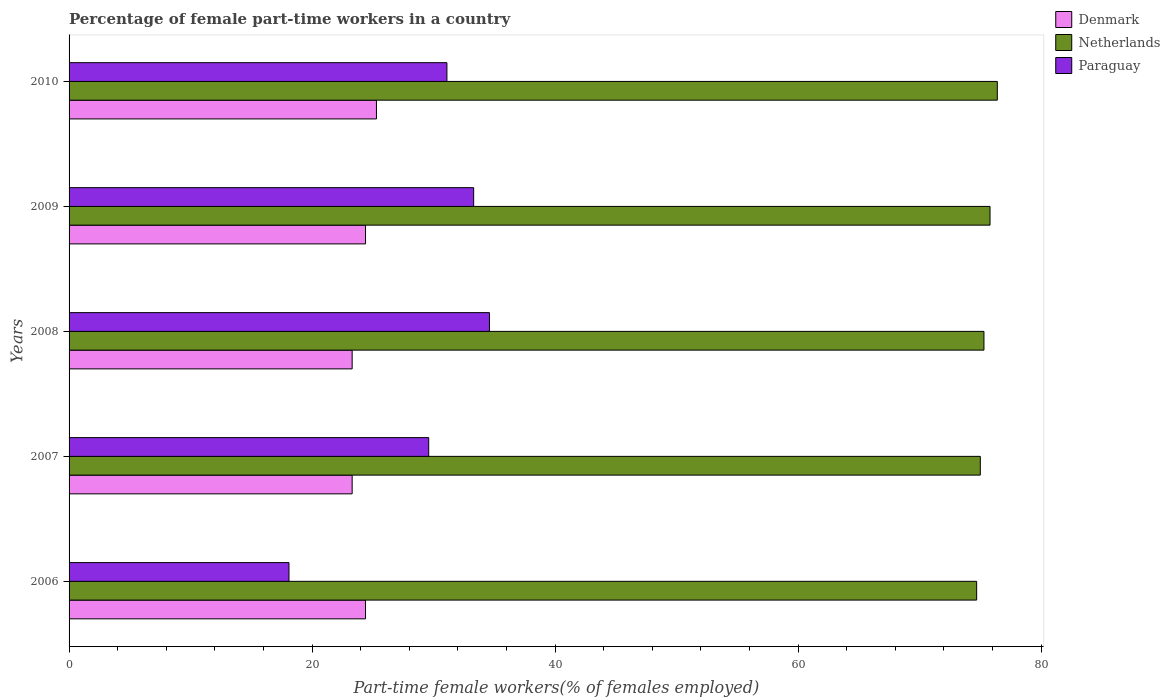How many different coloured bars are there?
Provide a short and direct response. 3. What is the label of the 2nd group of bars from the top?
Make the answer very short. 2009. What is the percentage of female part-time workers in Netherlands in 2009?
Your response must be concise. 75.8. Across all years, what is the maximum percentage of female part-time workers in Netherlands?
Your response must be concise. 76.4. Across all years, what is the minimum percentage of female part-time workers in Denmark?
Keep it short and to the point. 23.3. In which year was the percentage of female part-time workers in Netherlands maximum?
Your answer should be compact. 2010. What is the total percentage of female part-time workers in Paraguay in the graph?
Your response must be concise. 146.7. What is the difference between the percentage of female part-time workers in Paraguay in 2006 and that in 2009?
Your answer should be very brief. -15.2. What is the difference between the percentage of female part-time workers in Paraguay in 2010 and the percentage of female part-time workers in Denmark in 2007?
Your answer should be very brief. 7.8. What is the average percentage of female part-time workers in Netherlands per year?
Offer a very short reply. 75.44. In the year 2010, what is the difference between the percentage of female part-time workers in Denmark and percentage of female part-time workers in Paraguay?
Provide a short and direct response. -5.8. In how many years, is the percentage of female part-time workers in Paraguay greater than 60 %?
Your answer should be very brief. 0. What is the ratio of the percentage of female part-time workers in Denmark in 2006 to that in 2007?
Your answer should be compact. 1.05. What is the difference between the highest and the second highest percentage of female part-time workers in Denmark?
Provide a succinct answer. 0.9. What is the difference between the highest and the lowest percentage of female part-time workers in Netherlands?
Offer a very short reply. 1.7. In how many years, is the percentage of female part-time workers in Netherlands greater than the average percentage of female part-time workers in Netherlands taken over all years?
Give a very brief answer. 2. What does the 2nd bar from the top in 2006 represents?
Your answer should be compact. Netherlands. What does the 3rd bar from the bottom in 2009 represents?
Your answer should be compact. Paraguay. Is it the case that in every year, the sum of the percentage of female part-time workers in Denmark and percentage of female part-time workers in Netherlands is greater than the percentage of female part-time workers in Paraguay?
Make the answer very short. Yes. How many bars are there?
Offer a terse response. 15. How many years are there in the graph?
Provide a short and direct response. 5. Does the graph contain grids?
Keep it short and to the point. No. Where does the legend appear in the graph?
Give a very brief answer. Top right. What is the title of the graph?
Your response must be concise. Percentage of female part-time workers in a country. Does "Kosovo" appear as one of the legend labels in the graph?
Keep it short and to the point. No. What is the label or title of the X-axis?
Give a very brief answer. Part-time female workers(% of females employed). What is the Part-time female workers(% of females employed) of Denmark in 2006?
Offer a terse response. 24.4. What is the Part-time female workers(% of females employed) in Netherlands in 2006?
Offer a very short reply. 74.7. What is the Part-time female workers(% of females employed) of Paraguay in 2006?
Ensure brevity in your answer.  18.1. What is the Part-time female workers(% of females employed) in Denmark in 2007?
Your response must be concise. 23.3. What is the Part-time female workers(% of females employed) in Netherlands in 2007?
Offer a terse response. 75. What is the Part-time female workers(% of females employed) of Paraguay in 2007?
Offer a terse response. 29.6. What is the Part-time female workers(% of females employed) in Denmark in 2008?
Keep it short and to the point. 23.3. What is the Part-time female workers(% of females employed) in Netherlands in 2008?
Provide a short and direct response. 75.3. What is the Part-time female workers(% of females employed) in Paraguay in 2008?
Provide a succinct answer. 34.6. What is the Part-time female workers(% of females employed) in Denmark in 2009?
Give a very brief answer. 24.4. What is the Part-time female workers(% of females employed) in Netherlands in 2009?
Offer a very short reply. 75.8. What is the Part-time female workers(% of females employed) in Paraguay in 2009?
Your answer should be very brief. 33.3. What is the Part-time female workers(% of females employed) in Denmark in 2010?
Your response must be concise. 25.3. What is the Part-time female workers(% of females employed) of Netherlands in 2010?
Provide a succinct answer. 76.4. What is the Part-time female workers(% of females employed) of Paraguay in 2010?
Your response must be concise. 31.1. Across all years, what is the maximum Part-time female workers(% of females employed) of Denmark?
Ensure brevity in your answer.  25.3. Across all years, what is the maximum Part-time female workers(% of females employed) of Netherlands?
Provide a short and direct response. 76.4. Across all years, what is the maximum Part-time female workers(% of females employed) in Paraguay?
Give a very brief answer. 34.6. Across all years, what is the minimum Part-time female workers(% of females employed) of Denmark?
Provide a short and direct response. 23.3. Across all years, what is the minimum Part-time female workers(% of females employed) in Netherlands?
Make the answer very short. 74.7. Across all years, what is the minimum Part-time female workers(% of females employed) in Paraguay?
Offer a terse response. 18.1. What is the total Part-time female workers(% of females employed) of Denmark in the graph?
Provide a succinct answer. 120.7. What is the total Part-time female workers(% of females employed) in Netherlands in the graph?
Provide a short and direct response. 377.2. What is the total Part-time female workers(% of females employed) in Paraguay in the graph?
Make the answer very short. 146.7. What is the difference between the Part-time female workers(% of females employed) in Denmark in 2006 and that in 2007?
Ensure brevity in your answer.  1.1. What is the difference between the Part-time female workers(% of females employed) in Netherlands in 2006 and that in 2007?
Provide a succinct answer. -0.3. What is the difference between the Part-time female workers(% of females employed) in Netherlands in 2006 and that in 2008?
Keep it short and to the point. -0.6. What is the difference between the Part-time female workers(% of females employed) in Paraguay in 2006 and that in 2008?
Your answer should be compact. -16.5. What is the difference between the Part-time female workers(% of females employed) of Netherlands in 2006 and that in 2009?
Provide a short and direct response. -1.1. What is the difference between the Part-time female workers(% of females employed) in Paraguay in 2006 and that in 2009?
Your answer should be very brief. -15.2. What is the difference between the Part-time female workers(% of females employed) in Denmark in 2006 and that in 2010?
Provide a succinct answer. -0.9. What is the difference between the Part-time female workers(% of females employed) in Netherlands in 2006 and that in 2010?
Your response must be concise. -1.7. What is the difference between the Part-time female workers(% of females employed) in Denmark in 2007 and that in 2008?
Provide a succinct answer. 0. What is the difference between the Part-time female workers(% of females employed) in Paraguay in 2007 and that in 2008?
Make the answer very short. -5. What is the difference between the Part-time female workers(% of females employed) of Netherlands in 2007 and that in 2009?
Provide a short and direct response. -0.8. What is the difference between the Part-time female workers(% of females employed) in Paraguay in 2007 and that in 2010?
Offer a very short reply. -1.5. What is the difference between the Part-time female workers(% of females employed) of Paraguay in 2008 and that in 2009?
Offer a very short reply. 1.3. What is the difference between the Part-time female workers(% of females employed) in Netherlands in 2009 and that in 2010?
Your answer should be very brief. -0.6. What is the difference between the Part-time female workers(% of females employed) of Paraguay in 2009 and that in 2010?
Your answer should be compact. 2.2. What is the difference between the Part-time female workers(% of females employed) of Denmark in 2006 and the Part-time female workers(% of females employed) of Netherlands in 2007?
Provide a short and direct response. -50.6. What is the difference between the Part-time female workers(% of females employed) in Netherlands in 2006 and the Part-time female workers(% of females employed) in Paraguay in 2007?
Your answer should be very brief. 45.1. What is the difference between the Part-time female workers(% of females employed) in Denmark in 2006 and the Part-time female workers(% of females employed) in Netherlands in 2008?
Offer a very short reply. -50.9. What is the difference between the Part-time female workers(% of females employed) in Netherlands in 2006 and the Part-time female workers(% of females employed) in Paraguay in 2008?
Make the answer very short. 40.1. What is the difference between the Part-time female workers(% of females employed) in Denmark in 2006 and the Part-time female workers(% of females employed) in Netherlands in 2009?
Your answer should be very brief. -51.4. What is the difference between the Part-time female workers(% of females employed) of Denmark in 2006 and the Part-time female workers(% of females employed) of Paraguay in 2009?
Give a very brief answer. -8.9. What is the difference between the Part-time female workers(% of females employed) of Netherlands in 2006 and the Part-time female workers(% of females employed) of Paraguay in 2009?
Give a very brief answer. 41.4. What is the difference between the Part-time female workers(% of females employed) of Denmark in 2006 and the Part-time female workers(% of females employed) of Netherlands in 2010?
Your answer should be very brief. -52. What is the difference between the Part-time female workers(% of females employed) in Netherlands in 2006 and the Part-time female workers(% of females employed) in Paraguay in 2010?
Keep it short and to the point. 43.6. What is the difference between the Part-time female workers(% of females employed) in Denmark in 2007 and the Part-time female workers(% of females employed) in Netherlands in 2008?
Ensure brevity in your answer.  -52. What is the difference between the Part-time female workers(% of females employed) of Denmark in 2007 and the Part-time female workers(% of females employed) of Paraguay in 2008?
Give a very brief answer. -11.3. What is the difference between the Part-time female workers(% of females employed) in Netherlands in 2007 and the Part-time female workers(% of females employed) in Paraguay in 2008?
Give a very brief answer. 40.4. What is the difference between the Part-time female workers(% of females employed) of Denmark in 2007 and the Part-time female workers(% of females employed) of Netherlands in 2009?
Provide a short and direct response. -52.5. What is the difference between the Part-time female workers(% of females employed) in Denmark in 2007 and the Part-time female workers(% of females employed) in Paraguay in 2009?
Provide a short and direct response. -10. What is the difference between the Part-time female workers(% of females employed) in Netherlands in 2007 and the Part-time female workers(% of females employed) in Paraguay in 2009?
Provide a short and direct response. 41.7. What is the difference between the Part-time female workers(% of females employed) of Denmark in 2007 and the Part-time female workers(% of females employed) of Netherlands in 2010?
Give a very brief answer. -53.1. What is the difference between the Part-time female workers(% of females employed) of Netherlands in 2007 and the Part-time female workers(% of females employed) of Paraguay in 2010?
Your answer should be very brief. 43.9. What is the difference between the Part-time female workers(% of females employed) of Denmark in 2008 and the Part-time female workers(% of females employed) of Netherlands in 2009?
Make the answer very short. -52.5. What is the difference between the Part-time female workers(% of females employed) of Denmark in 2008 and the Part-time female workers(% of females employed) of Paraguay in 2009?
Your response must be concise. -10. What is the difference between the Part-time female workers(% of females employed) in Netherlands in 2008 and the Part-time female workers(% of females employed) in Paraguay in 2009?
Provide a short and direct response. 42. What is the difference between the Part-time female workers(% of females employed) of Denmark in 2008 and the Part-time female workers(% of females employed) of Netherlands in 2010?
Your answer should be compact. -53.1. What is the difference between the Part-time female workers(% of females employed) of Denmark in 2008 and the Part-time female workers(% of females employed) of Paraguay in 2010?
Make the answer very short. -7.8. What is the difference between the Part-time female workers(% of females employed) of Netherlands in 2008 and the Part-time female workers(% of females employed) of Paraguay in 2010?
Your response must be concise. 44.2. What is the difference between the Part-time female workers(% of females employed) in Denmark in 2009 and the Part-time female workers(% of females employed) in Netherlands in 2010?
Provide a short and direct response. -52. What is the difference between the Part-time female workers(% of females employed) of Netherlands in 2009 and the Part-time female workers(% of females employed) of Paraguay in 2010?
Give a very brief answer. 44.7. What is the average Part-time female workers(% of females employed) in Denmark per year?
Keep it short and to the point. 24.14. What is the average Part-time female workers(% of females employed) of Netherlands per year?
Your response must be concise. 75.44. What is the average Part-time female workers(% of females employed) of Paraguay per year?
Keep it short and to the point. 29.34. In the year 2006, what is the difference between the Part-time female workers(% of females employed) of Denmark and Part-time female workers(% of females employed) of Netherlands?
Ensure brevity in your answer.  -50.3. In the year 2006, what is the difference between the Part-time female workers(% of females employed) of Netherlands and Part-time female workers(% of females employed) of Paraguay?
Keep it short and to the point. 56.6. In the year 2007, what is the difference between the Part-time female workers(% of females employed) of Denmark and Part-time female workers(% of females employed) of Netherlands?
Make the answer very short. -51.7. In the year 2007, what is the difference between the Part-time female workers(% of females employed) of Denmark and Part-time female workers(% of females employed) of Paraguay?
Offer a very short reply. -6.3. In the year 2007, what is the difference between the Part-time female workers(% of females employed) of Netherlands and Part-time female workers(% of females employed) of Paraguay?
Offer a terse response. 45.4. In the year 2008, what is the difference between the Part-time female workers(% of females employed) in Denmark and Part-time female workers(% of females employed) in Netherlands?
Your answer should be very brief. -52. In the year 2008, what is the difference between the Part-time female workers(% of females employed) of Netherlands and Part-time female workers(% of females employed) of Paraguay?
Offer a terse response. 40.7. In the year 2009, what is the difference between the Part-time female workers(% of females employed) in Denmark and Part-time female workers(% of females employed) in Netherlands?
Your answer should be compact. -51.4. In the year 2009, what is the difference between the Part-time female workers(% of females employed) of Denmark and Part-time female workers(% of females employed) of Paraguay?
Your answer should be very brief. -8.9. In the year 2009, what is the difference between the Part-time female workers(% of females employed) of Netherlands and Part-time female workers(% of females employed) of Paraguay?
Keep it short and to the point. 42.5. In the year 2010, what is the difference between the Part-time female workers(% of females employed) in Denmark and Part-time female workers(% of females employed) in Netherlands?
Provide a succinct answer. -51.1. In the year 2010, what is the difference between the Part-time female workers(% of females employed) of Denmark and Part-time female workers(% of females employed) of Paraguay?
Your response must be concise. -5.8. In the year 2010, what is the difference between the Part-time female workers(% of females employed) of Netherlands and Part-time female workers(% of females employed) of Paraguay?
Keep it short and to the point. 45.3. What is the ratio of the Part-time female workers(% of females employed) in Denmark in 2006 to that in 2007?
Make the answer very short. 1.05. What is the ratio of the Part-time female workers(% of females employed) of Paraguay in 2006 to that in 2007?
Give a very brief answer. 0.61. What is the ratio of the Part-time female workers(% of females employed) in Denmark in 2006 to that in 2008?
Keep it short and to the point. 1.05. What is the ratio of the Part-time female workers(% of females employed) in Netherlands in 2006 to that in 2008?
Give a very brief answer. 0.99. What is the ratio of the Part-time female workers(% of females employed) in Paraguay in 2006 to that in 2008?
Your response must be concise. 0.52. What is the ratio of the Part-time female workers(% of females employed) in Denmark in 2006 to that in 2009?
Give a very brief answer. 1. What is the ratio of the Part-time female workers(% of females employed) of Netherlands in 2006 to that in 2009?
Offer a very short reply. 0.99. What is the ratio of the Part-time female workers(% of females employed) in Paraguay in 2006 to that in 2009?
Make the answer very short. 0.54. What is the ratio of the Part-time female workers(% of females employed) in Denmark in 2006 to that in 2010?
Provide a short and direct response. 0.96. What is the ratio of the Part-time female workers(% of females employed) of Netherlands in 2006 to that in 2010?
Offer a terse response. 0.98. What is the ratio of the Part-time female workers(% of females employed) in Paraguay in 2006 to that in 2010?
Make the answer very short. 0.58. What is the ratio of the Part-time female workers(% of females employed) of Denmark in 2007 to that in 2008?
Your response must be concise. 1. What is the ratio of the Part-time female workers(% of females employed) of Netherlands in 2007 to that in 2008?
Offer a terse response. 1. What is the ratio of the Part-time female workers(% of females employed) in Paraguay in 2007 to that in 2008?
Give a very brief answer. 0.86. What is the ratio of the Part-time female workers(% of females employed) in Denmark in 2007 to that in 2009?
Your answer should be very brief. 0.95. What is the ratio of the Part-time female workers(% of females employed) of Netherlands in 2007 to that in 2009?
Make the answer very short. 0.99. What is the ratio of the Part-time female workers(% of females employed) in Denmark in 2007 to that in 2010?
Give a very brief answer. 0.92. What is the ratio of the Part-time female workers(% of females employed) of Netherlands in 2007 to that in 2010?
Make the answer very short. 0.98. What is the ratio of the Part-time female workers(% of females employed) in Paraguay in 2007 to that in 2010?
Offer a very short reply. 0.95. What is the ratio of the Part-time female workers(% of females employed) in Denmark in 2008 to that in 2009?
Offer a terse response. 0.95. What is the ratio of the Part-time female workers(% of females employed) in Netherlands in 2008 to that in 2009?
Offer a terse response. 0.99. What is the ratio of the Part-time female workers(% of females employed) in Paraguay in 2008 to that in 2009?
Provide a succinct answer. 1.04. What is the ratio of the Part-time female workers(% of females employed) in Denmark in 2008 to that in 2010?
Your response must be concise. 0.92. What is the ratio of the Part-time female workers(% of females employed) of Netherlands in 2008 to that in 2010?
Offer a terse response. 0.99. What is the ratio of the Part-time female workers(% of females employed) in Paraguay in 2008 to that in 2010?
Your answer should be compact. 1.11. What is the ratio of the Part-time female workers(% of females employed) of Denmark in 2009 to that in 2010?
Your answer should be very brief. 0.96. What is the ratio of the Part-time female workers(% of females employed) in Paraguay in 2009 to that in 2010?
Offer a very short reply. 1.07. What is the difference between the highest and the second highest Part-time female workers(% of females employed) in Paraguay?
Give a very brief answer. 1.3. What is the difference between the highest and the lowest Part-time female workers(% of females employed) in Netherlands?
Offer a very short reply. 1.7. What is the difference between the highest and the lowest Part-time female workers(% of females employed) of Paraguay?
Make the answer very short. 16.5. 